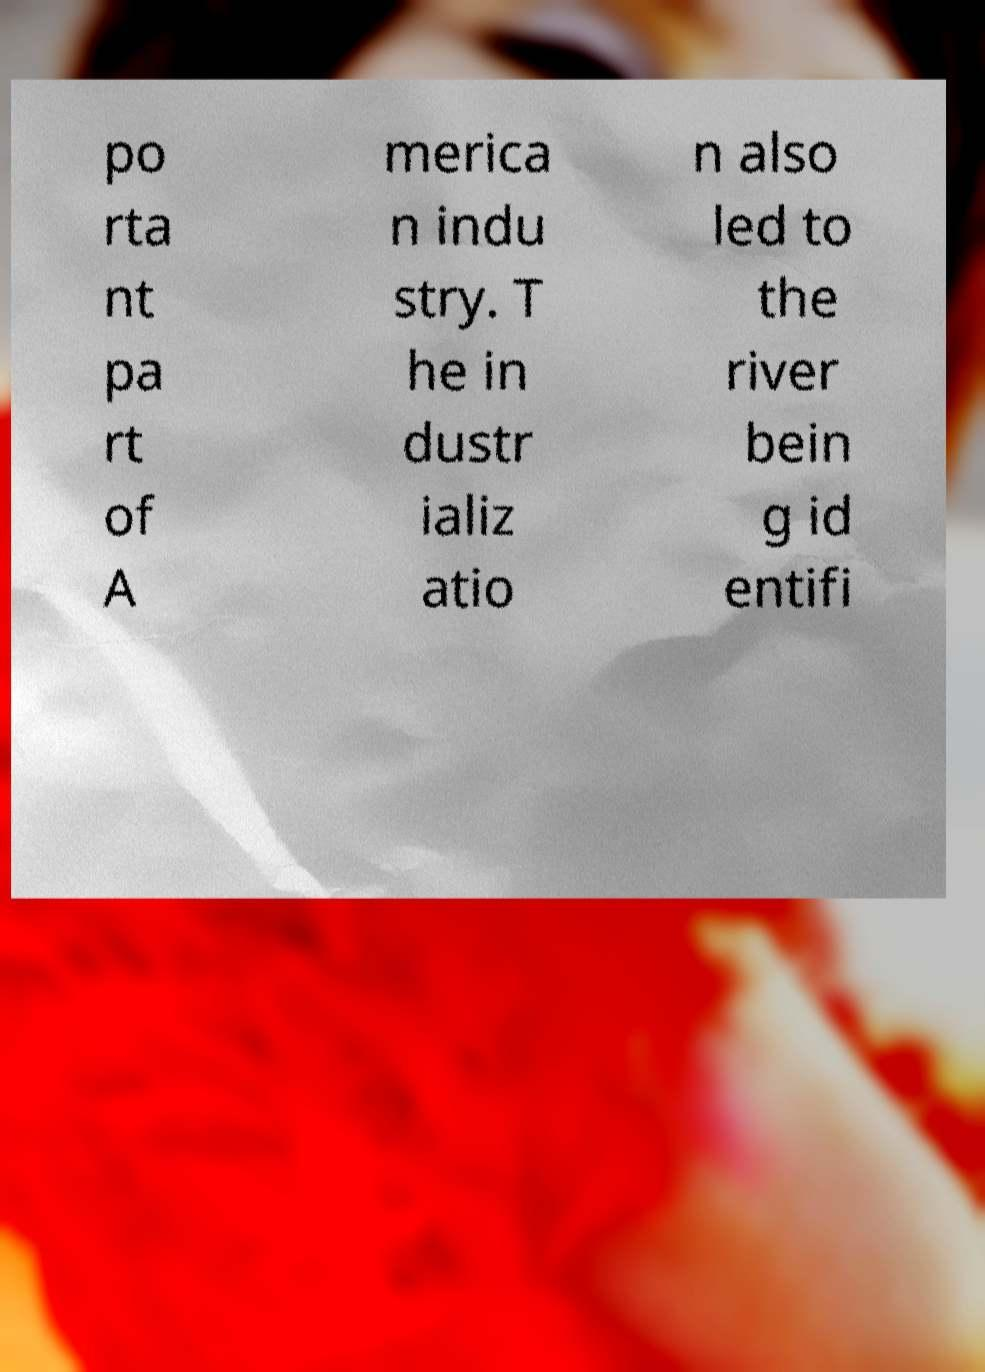I need the written content from this picture converted into text. Can you do that? po rta nt pa rt of A merica n indu stry. T he in dustr ializ atio n also led to the river bein g id entifi 